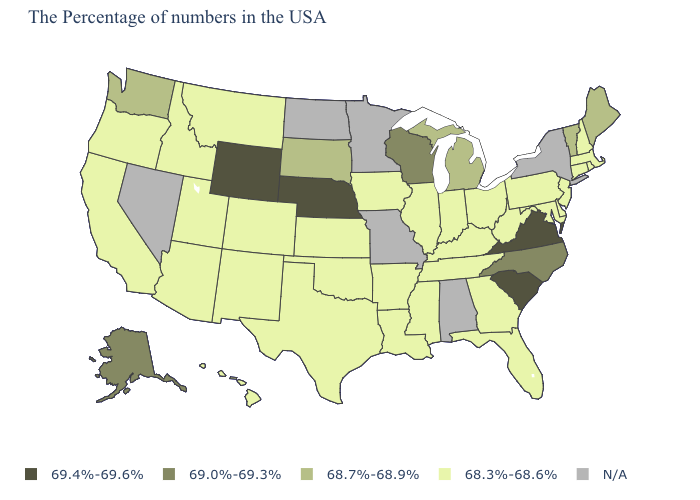What is the lowest value in states that border Pennsylvania?
Concise answer only. 68.3%-68.6%. Among the states that border New Hampshire , which have the highest value?
Keep it brief. Maine, Vermont. What is the value of Wyoming?
Be succinct. 69.4%-69.6%. Which states have the lowest value in the USA?
Keep it brief. Massachusetts, Rhode Island, New Hampshire, Connecticut, New Jersey, Delaware, Maryland, Pennsylvania, West Virginia, Ohio, Florida, Georgia, Kentucky, Indiana, Tennessee, Illinois, Mississippi, Louisiana, Arkansas, Iowa, Kansas, Oklahoma, Texas, Colorado, New Mexico, Utah, Montana, Arizona, Idaho, California, Oregon, Hawaii. What is the highest value in the USA?
Write a very short answer. 69.4%-69.6%. Name the states that have a value in the range 68.3%-68.6%?
Write a very short answer. Massachusetts, Rhode Island, New Hampshire, Connecticut, New Jersey, Delaware, Maryland, Pennsylvania, West Virginia, Ohio, Florida, Georgia, Kentucky, Indiana, Tennessee, Illinois, Mississippi, Louisiana, Arkansas, Iowa, Kansas, Oklahoma, Texas, Colorado, New Mexico, Utah, Montana, Arizona, Idaho, California, Oregon, Hawaii. Name the states that have a value in the range 69.4%-69.6%?
Give a very brief answer. Virginia, South Carolina, Nebraska, Wyoming. What is the value of Arizona?
Answer briefly. 68.3%-68.6%. Name the states that have a value in the range 68.7%-68.9%?
Write a very short answer. Maine, Vermont, Michigan, South Dakota, Washington. What is the lowest value in the MidWest?
Give a very brief answer. 68.3%-68.6%. Which states hav the highest value in the MidWest?
Give a very brief answer. Nebraska. Name the states that have a value in the range N/A?
Short answer required. New York, Alabama, Missouri, Minnesota, North Dakota, Nevada. Which states have the lowest value in the USA?
Concise answer only. Massachusetts, Rhode Island, New Hampshire, Connecticut, New Jersey, Delaware, Maryland, Pennsylvania, West Virginia, Ohio, Florida, Georgia, Kentucky, Indiana, Tennessee, Illinois, Mississippi, Louisiana, Arkansas, Iowa, Kansas, Oklahoma, Texas, Colorado, New Mexico, Utah, Montana, Arizona, Idaho, California, Oregon, Hawaii. Name the states that have a value in the range 69.4%-69.6%?
Quick response, please. Virginia, South Carolina, Nebraska, Wyoming. 